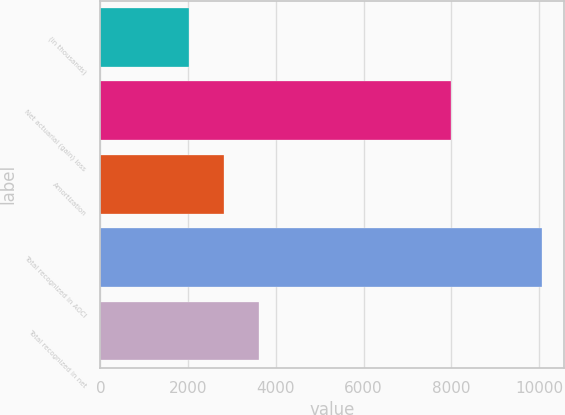Convert chart. <chart><loc_0><loc_0><loc_500><loc_500><bar_chart><fcel>(in thousands)<fcel>Net actuarial (gain) loss<fcel>Amortization<fcel>Total recognized in AOCI<fcel>Total recognized in net<nl><fcel>2009<fcel>7994<fcel>2814.1<fcel>10060<fcel>3619.2<nl></chart> 